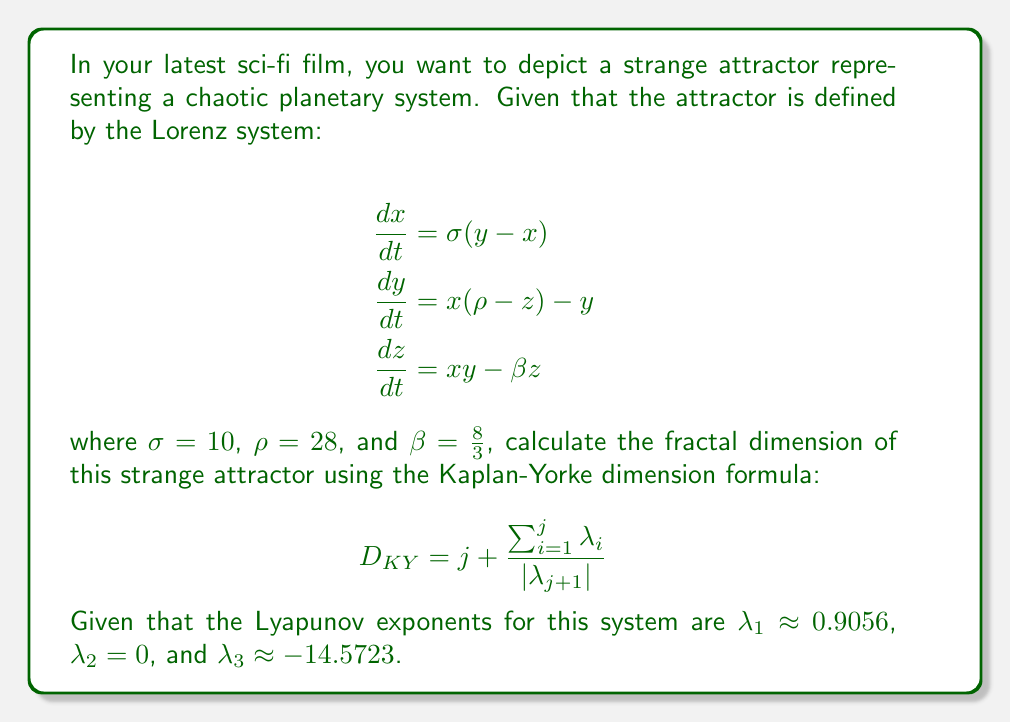Show me your answer to this math problem. To calculate the fractal dimension of the Lorenz attractor using the Kaplan-Yorke dimension formula, we follow these steps:

1) First, we need to determine the value of $j$. This is the largest integer for which the sum of the first $j$ Lyapunov exponents is non-negative:

   $\lambda_1 + \lambda_2 = 0.9056 + 0 = 0.9056 > 0$
   $\lambda_1 + \lambda_2 + \lambda_3 = 0.9056 + 0 - 14.5723 = -13.6667 < 0$

   Therefore, $j = 2$.

2) Now we can apply the Kaplan-Yorke dimension formula:

   $$D_{KY} = j + \frac{\sum_{i=1}^j \lambda_i}{|\lambda_{j+1}|}$$

3) Substituting the values:

   $$D_{KY} = 2 + \frac{\lambda_1 + \lambda_2}{|\lambda_3|}$$

4) Plugging in the numerical values:

   $$D_{KY} = 2 + \frac{0.9056 + 0}{|-14.5723|}$$

5) Simplifying:

   $$D_{KY} = 2 + \frac{0.9056}{14.5723}$$

6) Calculating the final result:

   $$D_{KY} \approx 2.0621$$

This fractal dimension, being between 2 and 3, indicates that the Lorenz attractor is indeed a strange attractor, with a structure more complex than a surface but not quite filling a volume.
Answer: $D_{KY} \approx 2.0621$ 